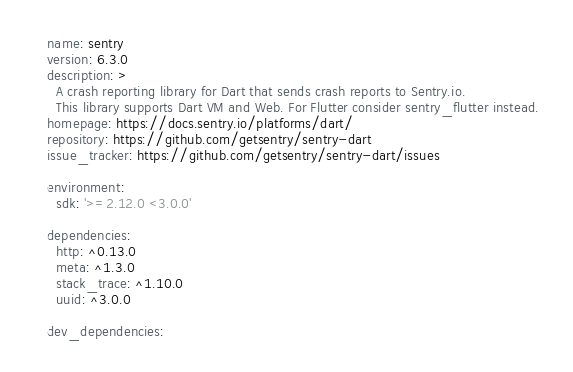Convert code to text. <code><loc_0><loc_0><loc_500><loc_500><_YAML_>name: sentry
version: 6.3.0
description: >
  A crash reporting library for Dart that sends crash reports to Sentry.io.
  This library supports Dart VM and Web. For Flutter consider sentry_flutter instead.
homepage: https://docs.sentry.io/platforms/dart/
repository: https://github.com/getsentry/sentry-dart
issue_tracker: https://github.com/getsentry/sentry-dart/issues

environment:
  sdk: '>=2.12.0 <3.0.0'

dependencies:
  http: ^0.13.0
  meta: ^1.3.0
  stack_trace: ^1.10.0
  uuid: ^3.0.0

dev_dependencies:</code> 